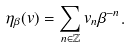Convert formula to latex. <formula><loc_0><loc_0><loc_500><loc_500>\eta _ { \beta } ( v ) = \sum _ { n \in \mathbb { Z } } v _ { n } \beta ^ { - n } .</formula> 